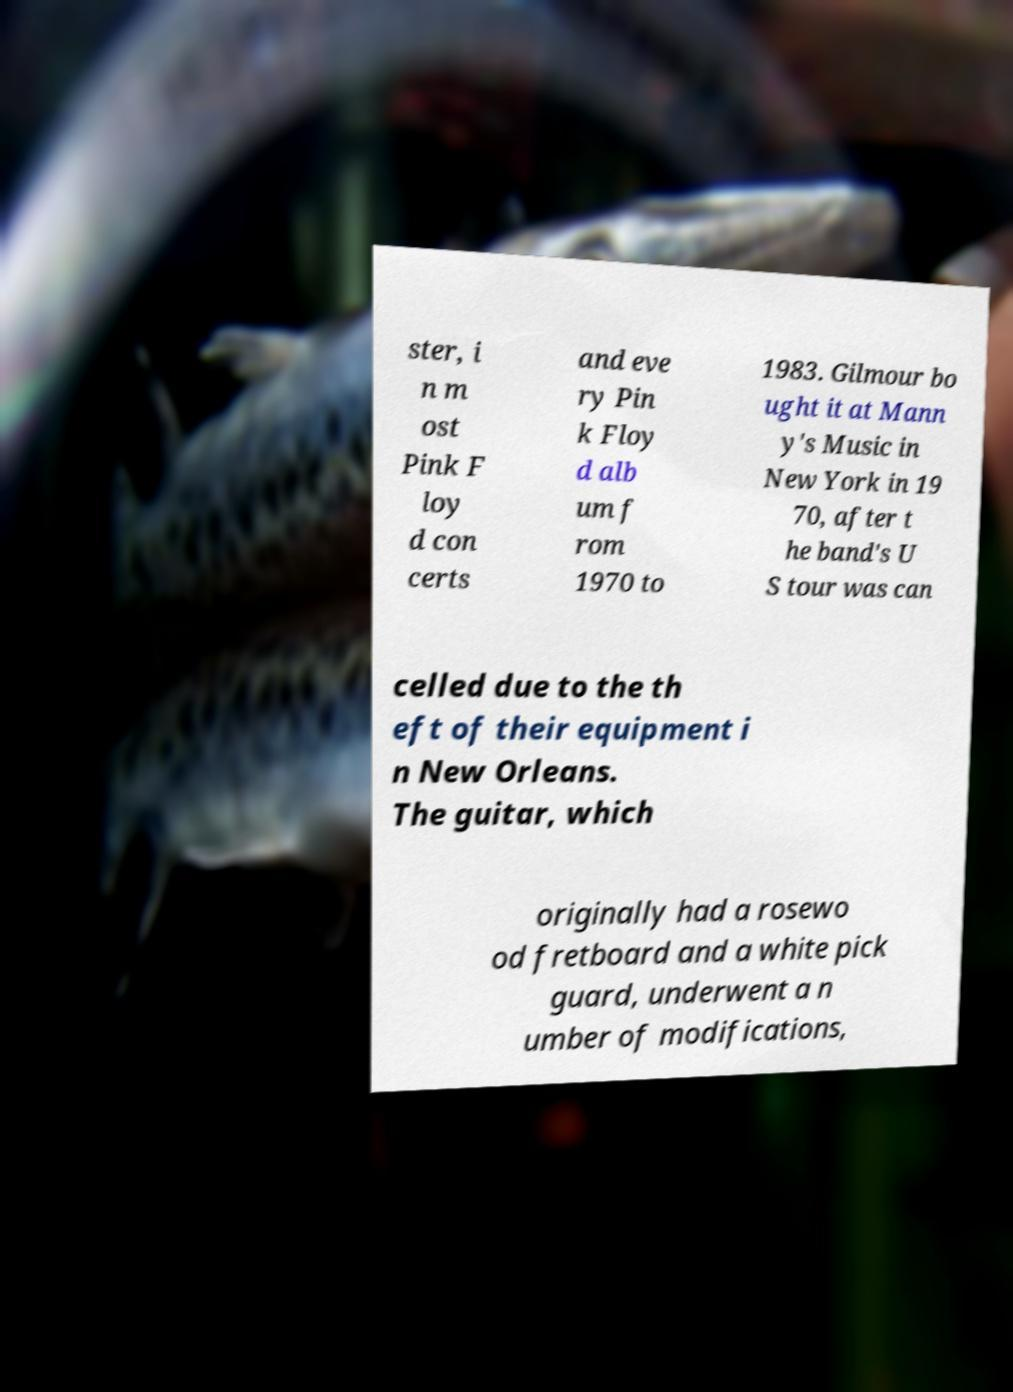Could you assist in decoding the text presented in this image and type it out clearly? ster, i n m ost Pink F loy d con certs and eve ry Pin k Floy d alb um f rom 1970 to 1983. Gilmour bo ught it at Mann y's Music in New York in 19 70, after t he band's U S tour was can celled due to the th eft of their equipment i n New Orleans. The guitar, which originally had a rosewo od fretboard and a white pick guard, underwent a n umber of modifications, 